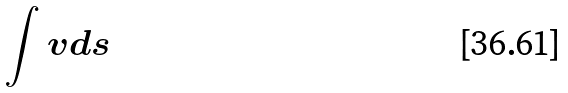Convert formula to latex. <formula><loc_0><loc_0><loc_500><loc_500>\int v d s</formula> 